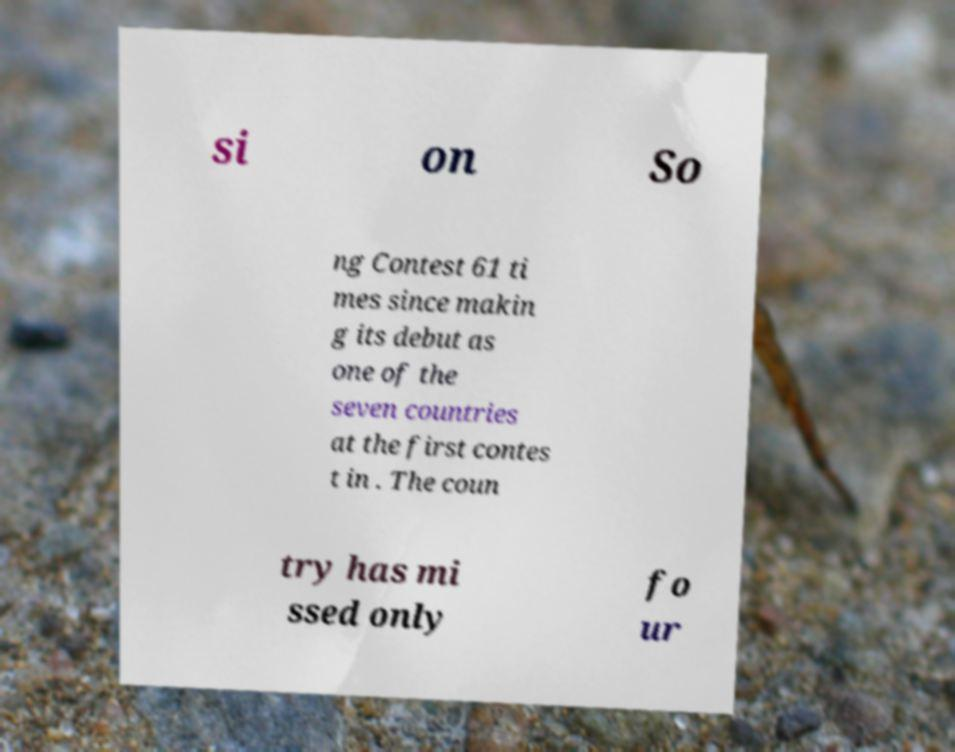What messages or text are displayed in this image? I need them in a readable, typed format. si on So ng Contest 61 ti mes since makin g its debut as one of the seven countries at the first contes t in . The coun try has mi ssed only fo ur 